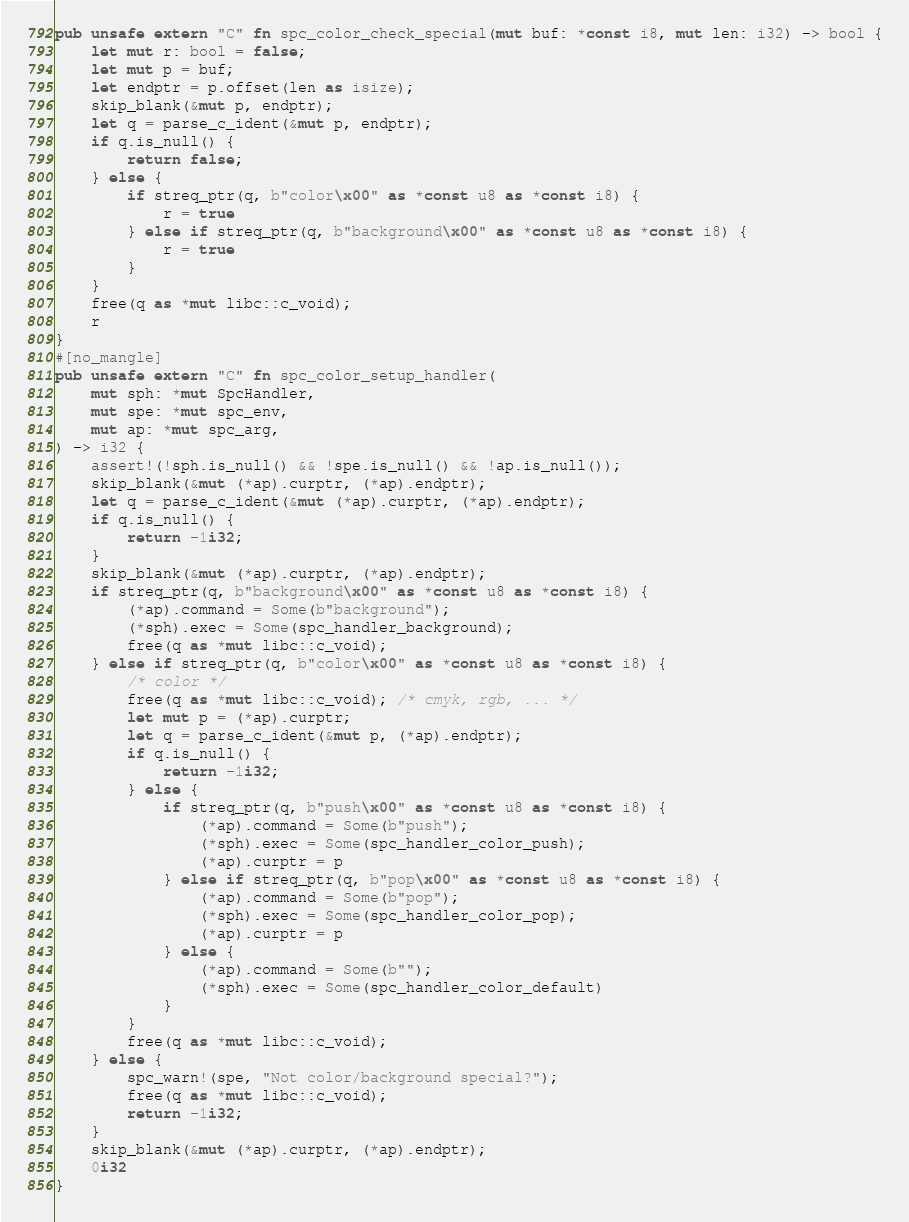Convert code to text. <code><loc_0><loc_0><loc_500><loc_500><_Rust_>pub unsafe extern "C" fn spc_color_check_special(mut buf: *const i8, mut len: i32) -> bool {
    let mut r: bool = false;
    let mut p = buf;
    let endptr = p.offset(len as isize);
    skip_blank(&mut p, endptr);
    let q = parse_c_ident(&mut p, endptr);
    if q.is_null() {
        return false;
    } else {
        if streq_ptr(q, b"color\x00" as *const u8 as *const i8) {
            r = true
        } else if streq_ptr(q, b"background\x00" as *const u8 as *const i8) {
            r = true
        }
    }
    free(q as *mut libc::c_void);
    r
}
#[no_mangle]
pub unsafe extern "C" fn spc_color_setup_handler(
    mut sph: *mut SpcHandler,
    mut spe: *mut spc_env,
    mut ap: *mut spc_arg,
) -> i32 {
    assert!(!sph.is_null() && !spe.is_null() && !ap.is_null());
    skip_blank(&mut (*ap).curptr, (*ap).endptr);
    let q = parse_c_ident(&mut (*ap).curptr, (*ap).endptr);
    if q.is_null() {
        return -1i32;
    }
    skip_blank(&mut (*ap).curptr, (*ap).endptr);
    if streq_ptr(q, b"background\x00" as *const u8 as *const i8) {
        (*ap).command = Some(b"background");
        (*sph).exec = Some(spc_handler_background);
        free(q as *mut libc::c_void);
    } else if streq_ptr(q, b"color\x00" as *const u8 as *const i8) {
        /* color */
        free(q as *mut libc::c_void); /* cmyk, rgb, ... */
        let mut p = (*ap).curptr;
        let q = parse_c_ident(&mut p, (*ap).endptr);
        if q.is_null() {
            return -1i32;
        } else {
            if streq_ptr(q, b"push\x00" as *const u8 as *const i8) {
                (*ap).command = Some(b"push");
                (*sph).exec = Some(spc_handler_color_push);
                (*ap).curptr = p
            } else if streq_ptr(q, b"pop\x00" as *const u8 as *const i8) {
                (*ap).command = Some(b"pop");
                (*sph).exec = Some(spc_handler_color_pop);
                (*ap).curptr = p
            } else {
                (*ap).command = Some(b"");
                (*sph).exec = Some(spc_handler_color_default)
            }
        }
        free(q as *mut libc::c_void);
    } else {
        spc_warn!(spe, "Not color/background special?");
        free(q as *mut libc::c_void);
        return -1i32;
    }
    skip_blank(&mut (*ap).curptr, (*ap).endptr);
    0i32
}
</code> 